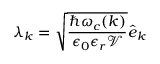<formula> <loc_0><loc_0><loc_500><loc_500>{ \boldsymbol \lambda } _ { \boldsymbol k } = \sqrt { \frac { \hbar { \omega } _ { c } ( { \boldsymbol k } ) } { { \epsilon _ { 0 } \epsilon _ { r } \mathcal { V } } } } \hat { \boldsymbol e } _ { \boldsymbol k }</formula> 